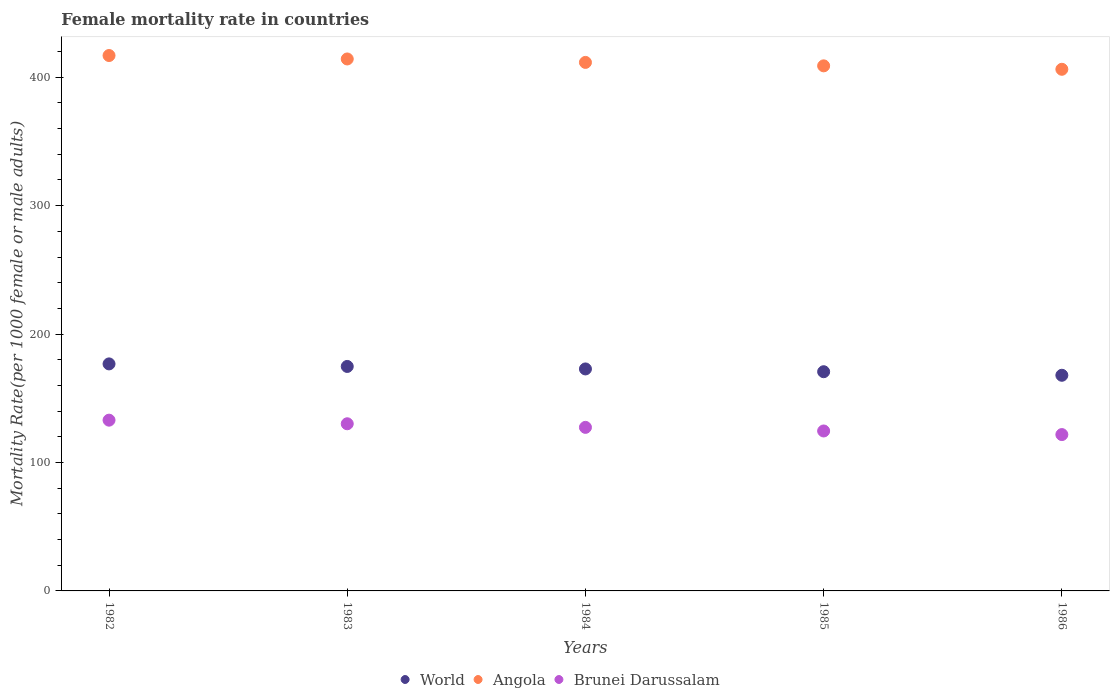Is the number of dotlines equal to the number of legend labels?
Your answer should be very brief. Yes. What is the female mortality rate in World in 1985?
Provide a succinct answer. 170.69. Across all years, what is the maximum female mortality rate in Angola?
Give a very brief answer. 416.9. Across all years, what is the minimum female mortality rate in Brunei Darussalam?
Your answer should be compact. 121.74. What is the total female mortality rate in Brunei Darussalam in the graph?
Provide a short and direct response. 636.77. What is the difference between the female mortality rate in Brunei Darussalam in 1983 and that in 1984?
Offer a terse response. 2.81. What is the difference between the female mortality rate in Brunei Darussalam in 1984 and the female mortality rate in Angola in 1986?
Give a very brief answer. -278.83. What is the average female mortality rate in Brunei Darussalam per year?
Your answer should be very brief. 127.35. In the year 1982, what is the difference between the female mortality rate in World and female mortality rate in Angola?
Make the answer very short. -240.12. What is the ratio of the female mortality rate in Angola in 1982 to that in 1986?
Provide a succinct answer. 1.03. Is the female mortality rate in World in 1984 less than that in 1985?
Provide a succinct answer. No. Is the difference between the female mortality rate in World in 1983 and 1986 greater than the difference between the female mortality rate in Angola in 1983 and 1986?
Offer a very short reply. No. What is the difference between the highest and the second highest female mortality rate in Brunei Darussalam?
Ensure brevity in your answer.  2.81. What is the difference between the highest and the lowest female mortality rate in Brunei Darussalam?
Offer a terse response. 11.22. In how many years, is the female mortality rate in Brunei Darussalam greater than the average female mortality rate in Brunei Darussalam taken over all years?
Your answer should be very brief. 2. Is the sum of the female mortality rate in Angola in 1982 and 1985 greater than the maximum female mortality rate in World across all years?
Your answer should be compact. Yes. Does the female mortality rate in World monotonically increase over the years?
Your answer should be very brief. No. Is the female mortality rate in Brunei Darussalam strictly greater than the female mortality rate in Angola over the years?
Make the answer very short. No. Is the female mortality rate in World strictly less than the female mortality rate in Brunei Darussalam over the years?
Ensure brevity in your answer.  No. Are the values on the major ticks of Y-axis written in scientific E-notation?
Offer a very short reply. No. Does the graph contain any zero values?
Offer a very short reply. No. Does the graph contain grids?
Offer a terse response. No. How are the legend labels stacked?
Your response must be concise. Horizontal. What is the title of the graph?
Your answer should be compact. Female mortality rate in countries. Does "Canada" appear as one of the legend labels in the graph?
Provide a short and direct response. No. What is the label or title of the X-axis?
Keep it short and to the point. Years. What is the label or title of the Y-axis?
Offer a very short reply. Mortality Rate(per 1000 female or male adults). What is the Mortality Rate(per 1000 female or male adults) of World in 1982?
Provide a succinct answer. 176.78. What is the Mortality Rate(per 1000 female or male adults) of Angola in 1982?
Your answer should be compact. 416.9. What is the Mortality Rate(per 1000 female or male adults) in Brunei Darussalam in 1982?
Offer a terse response. 132.97. What is the Mortality Rate(per 1000 female or male adults) in World in 1983?
Keep it short and to the point. 174.79. What is the Mortality Rate(per 1000 female or male adults) in Angola in 1983?
Offer a very short reply. 414.22. What is the Mortality Rate(per 1000 female or male adults) of Brunei Darussalam in 1983?
Provide a succinct answer. 130.16. What is the Mortality Rate(per 1000 female or male adults) in World in 1984?
Keep it short and to the point. 172.85. What is the Mortality Rate(per 1000 female or male adults) in Angola in 1984?
Offer a terse response. 411.54. What is the Mortality Rate(per 1000 female or male adults) in Brunei Darussalam in 1984?
Keep it short and to the point. 127.35. What is the Mortality Rate(per 1000 female or male adults) of World in 1985?
Keep it short and to the point. 170.69. What is the Mortality Rate(per 1000 female or male adults) in Angola in 1985?
Keep it short and to the point. 408.86. What is the Mortality Rate(per 1000 female or male adults) of Brunei Darussalam in 1985?
Ensure brevity in your answer.  124.55. What is the Mortality Rate(per 1000 female or male adults) in World in 1986?
Your answer should be very brief. 167.92. What is the Mortality Rate(per 1000 female or male adults) in Angola in 1986?
Provide a short and direct response. 406.19. What is the Mortality Rate(per 1000 female or male adults) of Brunei Darussalam in 1986?
Offer a terse response. 121.74. Across all years, what is the maximum Mortality Rate(per 1000 female or male adults) in World?
Provide a succinct answer. 176.78. Across all years, what is the maximum Mortality Rate(per 1000 female or male adults) of Angola?
Make the answer very short. 416.9. Across all years, what is the maximum Mortality Rate(per 1000 female or male adults) in Brunei Darussalam?
Provide a short and direct response. 132.97. Across all years, what is the minimum Mortality Rate(per 1000 female or male adults) of World?
Offer a very short reply. 167.92. Across all years, what is the minimum Mortality Rate(per 1000 female or male adults) of Angola?
Your answer should be compact. 406.19. Across all years, what is the minimum Mortality Rate(per 1000 female or male adults) of Brunei Darussalam?
Provide a succinct answer. 121.74. What is the total Mortality Rate(per 1000 female or male adults) in World in the graph?
Provide a succinct answer. 863.03. What is the total Mortality Rate(per 1000 female or male adults) in Angola in the graph?
Your answer should be compact. 2057.71. What is the total Mortality Rate(per 1000 female or male adults) of Brunei Darussalam in the graph?
Offer a terse response. 636.77. What is the difference between the Mortality Rate(per 1000 female or male adults) of World in 1982 and that in 1983?
Your answer should be very brief. 1.98. What is the difference between the Mortality Rate(per 1000 female or male adults) in Angola in 1982 and that in 1983?
Make the answer very short. 2.68. What is the difference between the Mortality Rate(per 1000 female or male adults) of Brunei Darussalam in 1982 and that in 1983?
Offer a terse response. 2.81. What is the difference between the Mortality Rate(per 1000 female or male adults) in World in 1982 and that in 1984?
Keep it short and to the point. 3.93. What is the difference between the Mortality Rate(per 1000 female or male adults) in Angola in 1982 and that in 1984?
Your answer should be compact. 5.36. What is the difference between the Mortality Rate(per 1000 female or male adults) in Brunei Darussalam in 1982 and that in 1984?
Provide a succinct answer. 5.61. What is the difference between the Mortality Rate(per 1000 female or male adults) in World in 1982 and that in 1985?
Make the answer very short. 6.09. What is the difference between the Mortality Rate(per 1000 female or male adults) of Angola in 1982 and that in 1985?
Your answer should be compact. 8.04. What is the difference between the Mortality Rate(per 1000 female or male adults) in Brunei Darussalam in 1982 and that in 1985?
Ensure brevity in your answer.  8.42. What is the difference between the Mortality Rate(per 1000 female or male adults) of World in 1982 and that in 1986?
Offer a terse response. 8.86. What is the difference between the Mortality Rate(per 1000 female or male adults) in Angola in 1982 and that in 1986?
Offer a terse response. 10.71. What is the difference between the Mortality Rate(per 1000 female or male adults) in Brunei Darussalam in 1982 and that in 1986?
Provide a succinct answer. 11.22. What is the difference between the Mortality Rate(per 1000 female or male adults) of World in 1983 and that in 1984?
Provide a succinct answer. 1.94. What is the difference between the Mortality Rate(per 1000 female or male adults) of Angola in 1983 and that in 1984?
Make the answer very short. 2.68. What is the difference between the Mortality Rate(per 1000 female or male adults) of Brunei Darussalam in 1983 and that in 1984?
Give a very brief answer. 2.81. What is the difference between the Mortality Rate(per 1000 female or male adults) in World in 1983 and that in 1985?
Your response must be concise. 4.1. What is the difference between the Mortality Rate(per 1000 female or male adults) of Angola in 1983 and that in 1985?
Offer a terse response. 5.36. What is the difference between the Mortality Rate(per 1000 female or male adults) of Brunei Darussalam in 1983 and that in 1985?
Give a very brief answer. 5.61. What is the difference between the Mortality Rate(per 1000 female or male adults) of World in 1983 and that in 1986?
Your response must be concise. 6.88. What is the difference between the Mortality Rate(per 1000 female or male adults) in Angola in 1983 and that in 1986?
Offer a terse response. 8.04. What is the difference between the Mortality Rate(per 1000 female or male adults) in Brunei Darussalam in 1983 and that in 1986?
Offer a terse response. 8.42. What is the difference between the Mortality Rate(per 1000 female or male adults) in World in 1984 and that in 1985?
Provide a succinct answer. 2.16. What is the difference between the Mortality Rate(per 1000 female or male adults) of Angola in 1984 and that in 1985?
Ensure brevity in your answer.  2.68. What is the difference between the Mortality Rate(per 1000 female or male adults) in Brunei Darussalam in 1984 and that in 1985?
Provide a succinct answer. 2.81. What is the difference between the Mortality Rate(per 1000 female or male adults) of World in 1984 and that in 1986?
Provide a short and direct response. 4.93. What is the difference between the Mortality Rate(per 1000 female or male adults) of Angola in 1984 and that in 1986?
Offer a very short reply. 5.36. What is the difference between the Mortality Rate(per 1000 female or male adults) of Brunei Darussalam in 1984 and that in 1986?
Your answer should be compact. 5.61. What is the difference between the Mortality Rate(per 1000 female or male adults) of World in 1985 and that in 1986?
Offer a terse response. 2.77. What is the difference between the Mortality Rate(per 1000 female or male adults) of Angola in 1985 and that in 1986?
Make the answer very short. 2.68. What is the difference between the Mortality Rate(per 1000 female or male adults) in Brunei Darussalam in 1985 and that in 1986?
Offer a very short reply. 2.81. What is the difference between the Mortality Rate(per 1000 female or male adults) of World in 1982 and the Mortality Rate(per 1000 female or male adults) of Angola in 1983?
Make the answer very short. -237.44. What is the difference between the Mortality Rate(per 1000 female or male adults) in World in 1982 and the Mortality Rate(per 1000 female or male adults) in Brunei Darussalam in 1983?
Provide a succinct answer. 46.62. What is the difference between the Mortality Rate(per 1000 female or male adults) of Angola in 1982 and the Mortality Rate(per 1000 female or male adults) of Brunei Darussalam in 1983?
Your response must be concise. 286.74. What is the difference between the Mortality Rate(per 1000 female or male adults) in World in 1982 and the Mortality Rate(per 1000 female or male adults) in Angola in 1984?
Provide a short and direct response. -234.76. What is the difference between the Mortality Rate(per 1000 female or male adults) in World in 1982 and the Mortality Rate(per 1000 female or male adults) in Brunei Darussalam in 1984?
Provide a succinct answer. 49.42. What is the difference between the Mortality Rate(per 1000 female or male adults) in Angola in 1982 and the Mortality Rate(per 1000 female or male adults) in Brunei Darussalam in 1984?
Offer a very short reply. 289.55. What is the difference between the Mortality Rate(per 1000 female or male adults) of World in 1982 and the Mortality Rate(per 1000 female or male adults) of Angola in 1985?
Your response must be concise. -232.09. What is the difference between the Mortality Rate(per 1000 female or male adults) of World in 1982 and the Mortality Rate(per 1000 female or male adults) of Brunei Darussalam in 1985?
Give a very brief answer. 52.23. What is the difference between the Mortality Rate(per 1000 female or male adults) in Angola in 1982 and the Mortality Rate(per 1000 female or male adults) in Brunei Darussalam in 1985?
Offer a terse response. 292.35. What is the difference between the Mortality Rate(per 1000 female or male adults) of World in 1982 and the Mortality Rate(per 1000 female or male adults) of Angola in 1986?
Make the answer very short. -229.41. What is the difference between the Mortality Rate(per 1000 female or male adults) in World in 1982 and the Mortality Rate(per 1000 female or male adults) in Brunei Darussalam in 1986?
Your answer should be very brief. 55.04. What is the difference between the Mortality Rate(per 1000 female or male adults) in Angola in 1982 and the Mortality Rate(per 1000 female or male adults) in Brunei Darussalam in 1986?
Make the answer very short. 295.16. What is the difference between the Mortality Rate(per 1000 female or male adults) in World in 1983 and the Mortality Rate(per 1000 female or male adults) in Angola in 1984?
Offer a terse response. -236.75. What is the difference between the Mortality Rate(per 1000 female or male adults) of World in 1983 and the Mortality Rate(per 1000 female or male adults) of Brunei Darussalam in 1984?
Provide a succinct answer. 47.44. What is the difference between the Mortality Rate(per 1000 female or male adults) of Angola in 1983 and the Mortality Rate(per 1000 female or male adults) of Brunei Darussalam in 1984?
Provide a succinct answer. 286.87. What is the difference between the Mortality Rate(per 1000 female or male adults) of World in 1983 and the Mortality Rate(per 1000 female or male adults) of Angola in 1985?
Your answer should be very brief. -234.07. What is the difference between the Mortality Rate(per 1000 female or male adults) of World in 1983 and the Mortality Rate(per 1000 female or male adults) of Brunei Darussalam in 1985?
Give a very brief answer. 50.24. What is the difference between the Mortality Rate(per 1000 female or male adults) of Angola in 1983 and the Mortality Rate(per 1000 female or male adults) of Brunei Darussalam in 1985?
Keep it short and to the point. 289.67. What is the difference between the Mortality Rate(per 1000 female or male adults) of World in 1983 and the Mortality Rate(per 1000 female or male adults) of Angola in 1986?
Keep it short and to the point. -231.39. What is the difference between the Mortality Rate(per 1000 female or male adults) of World in 1983 and the Mortality Rate(per 1000 female or male adults) of Brunei Darussalam in 1986?
Provide a short and direct response. 53.05. What is the difference between the Mortality Rate(per 1000 female or male adults) of Angola in 1983 and the Mortality Rate(per 1000 female or male adults) of Brunei Darussalam in 1986?
Provide a short and direct response. 292.48. What is the difference between the Mortality Rate(per 1000 female or male adults) in World in 1984 and the Mortality Rate(per 1000 female or male adults) in Angola in 1985?
Make the answer very short. -236.01. What is the difference between the Mortality Rate(per 1000 female or male adults) of World in 1984 and the Mortality Rate(per 1000 female or male adults) of Brunei Darussalam in 1985?
Keep it short and to the point. 48.3. What is the difference between the Mortality Rate(per 1000 female or male adults) in Angola in 1984 and the Mortality Rate(per 1000 female or male adults) in Brunei Darussalam in 1985?
Make the answer very short. 286.99. What is the difference between the Mortality Rate(per 1000 female or male adults) in World in 1984 and the Mortality Rate(per 1000 female or male adults) in Angola in 1986?
Provide a succinct answer. -233.33. What is the difference between the Mortality Rate(per 1000 female or male adults) of World in 1984 and the Mortality Rate(per 1000 female or male adults) of Brunei Darussalam in 1986?
Keep it short and to the point. 51.11. What is the difference between the Mortality Rate(per 1000 female or male adults) of Angola in 1984 and the Mortality Rate(per 1000 female or male adults) of Brunei Darussalam in 1986?
Make the answer very short. 289.8. What is the difference between the Mortality Rate(per 1000 female or male adults) of World in 1985 and the Mortality Rate(per 1000 female or male adults) of Angola in 1986?
Ensure brevity in your answer.  -235.5. What is the difference between the Mortality Rate(per 1000 female or male adults) in World in 1985 and the Mortality Rate(per 1000 female or male adults) in Brunei Darussalam in 1986?
Provide a short and direct response. 48.95. What is the difference between the Mortality Rate(per 1000 female or male adults) of Angola in 1985 and the Mortality Rate(per 1000 female or male adults) of Brunei Darussalam in 1986?
Your response must be concise. 287.12. What is the average Mortality Rate(per 1000 female or male adults) in World per year?
Give a very brief answer. 172.61. What is the average Mortality Rate(per 1000 female or male adults) of Angola per year?
Offer a very short reply. 411.54. What is the average Mortality Rate(per 1000 female or male adults) of Brunei Darussalam per year?
Your response must be concise. 127.35. In the year 1982, what is the difference between the Mortality Rate(per 1000 female or male adults) of World and Mortality Rate(per 1000 female or male adults) of Angola?
Provide a short and direct response. -240.12. In the year 1982, what is the difference between the Mortality Rate(per 1000 female or male adults) in World and Mortality Rate(per 1000 female or male adults) in Brunei Darussalam?
Give a very brief answer. 43.81. In the year 1982, what is the difference between the Mortality Rate(per 1000 female or male adults) of Angola and Mortality Rate(per 1000 female or male adults) of Brunei Darussalam?
Your answer should be very brief. 283.93. In the year 1983, what is the difference between the Mortality Rate(per 1000 female or male adults) in World and Mortality Rate(per 1000 female or male adults) in Angola?
Your response must be concise. -239.43. In the year 1983, what is the difference between the Mortality Rate(per 1000 female or male adults) of World and Mortality Rate(per 1000 female or male adults) of Brunei Darussalam?
Provide a short and direct response. 44.63. In the year 1983, what is the difference between the Mortality Rate(per 1000 female or male adults) in Angola and Mortality Rate(per 1000 female or male adults) in Brunei Darussalam?
Provide a short and direct response. 284.06. In the year 1984, what is the difference between the Mortality Rate(per 1000 female or male adults) in World and Mortality Rate(per 1000 female or male adults) in Angola?
Your answer should be very brief. -238.69. In the year 1984, what is the difference between the Mortality Rate(per 1000 female or male adults) of World and Mortality Rate(per 1000 female or male adults) of Brunei Darussalam?
Your answer should be compact. 45.5. In the year 1984, what is the difference between the Mortality Rate(per 1000 female or male adults) of Angola and Mortality Rate(per 1000 female or male adults) of Brunei Darussalam?
Your answer should be compact. 284.19. In the year 1985, what is the difference between the Mortality Rate(per 1000 female or male adults) in World and Mortality Rate(per 1000 female or male adults) in Angola?
Ensure brevity in your answer.  -238.18. In the year 1985, what is the difference between the Mortality Rate(per 1000 female or male adults) in World and Mortality Rate(per 1000 female or male adults) in Brunei Darussalam?
Your answer should be compact. 46.14. In the year 1985, what is the difference between the Mortality Rate(per 1000 female or male adults) in Angola and Mortality Rate(per 1000 female or male adults) in Brunei Darussalam?
Offer a very short reply. 284.32. In the year 1986, what is the difference between the Mortality Rate(per 1000 female or male adults) in World and Mortality Rate(per 1000 female or male adults) in Angola?
Your answer should be compact. -238.27. In the year 1986, what is the difference between the Mortality Rate(per 1000 female or male adults) in World and Mortality Rate(per 1000 female or male adults) in Brunei Darussalam?
Make the answer very short. 46.18. In the year 1986, what is the difference between the Mortality Rate(per 1000 female or male adults) in Angola and Mortality Rate(per 1000 female or male adults) in Brunei Darussalam?
Your answer should be compact. 284.44. What is the ratio of the Mortality Rate(per 1000 female or male adults) of World in 1982 to that in 1983?
Provide a short and direct response. 1.01. What is the ratio of the Mortality Rate(per 1000 female or male adults) in Brunei Darussalam in 1982 to that in 1983?
Offer a very short reply. 1.02. What is the ratio of the Mortality Rate(per 1000 female or male adults) of World in 1982 to that in 1984?
Keep it short and to the point. 1.02. What is the ratio of the Mortality Rate(per 1000 female or male adults) of Angola in 1982 to that in 1984?
Your response must be concise. 1.01. What is the ratio of the Mortality Rate(per 1000 female or male adults) in Brunei Darussalam in 1982 to that in 1984?
Your answer should be very brief. 1.04. What is the ratio of the Mortality Rate(per 1000 female or male adults) in World in 1982 to that in 1985?
Offer a very short reply. 1.04. What is the ratio of the Mortality Rate(per 1000 female or male adults) of Angola in 1982 to that in 1985?
Your answer should be very brief. 1.02. What is the ratio of the Mortality Rate(per 1000 female or male adults) in Brunei Darussalam in 1982 to that in 1985?
Your response must be concise. 1.07. What is the ratio of the Mortality Rate(per 1000 female or male adults) of World in 1982 to that in 1986?
Give a very brief answer. 1.05. What is the ratio of the Mortality Rate(per 1000 female or male adults) in Angola in 1982 to that in 1986?
Offer a very short reply. 1.03. What is the ratio of the Mortality Rate(per 1000 female or male adults) of Brunei Darussalam in 1982 to that in 1986?
Offer a very short reply. 1.09. What is the ratio of the Mortality Rate(per 1000 female or male adults) of World in 1983 to that in 1984?
Provide a succinct answer. 1.01. What is the ratio of the Mortality Rate(per 1000 female or male adults) of World in 1983 to that in 1985?
Provide a short and direct response. 1.02. What is the ratio of the Mortality Rate(per 1000 female or male adults) of Angola in 1983 to that in 1985?
Give a very brief answer. 1.01. What is the ratio of the Mortality Rate(per 1000 female or male adults) in Brunei Darussalam in 1983 to that in 1985?
Provide a short and direct response. 1.05. What is the ratio of the Mortality Rate(per 1000 female or male adults) of World in 1983 to that in 1986?
Offer a terse response. 1.04. What is the ratio of the Mortality Rate(per 1000 female or male adults) of Angola in 1983 to that in 1986?
Keep it short and to the point. 1.02. What is the ratio of the Mortality Rate(per 1000 female or male adults) in Brunei Darussalam in 1983 to that in 1986?
Ensure brevity in your answer.  1.07. What is the ratio of the Mortality Rate(per 1000 female or male adults) of World in 1984 to that in 1985?
Make the answer very short. 1.01. What is the ratio of the Mortality Rate(per 1000 female or male adults) in Angola in 1984 to that in 1985?
Keep it short and to the point. 1.01. What is the ratio of the Mortality Rate(per 1000 female or male adults) in Brunei Darussalam in 1984 to that in 1985?
Your answer should be compact. 1.02. What is the ratio of the Mortality Rate(per 1000 female or male adults) in World in 1984 to that in 1986?
Your answer should be compact. 1.03. What is the ratio of the Mortality Rate(per 1000 female or male adults) in Angola in 1984 to that in 1986?
Give a very brief answer. 1.01. What is the ratio of the Mortality Rate(per 1000 female or male adults) in Brunei Darussalam in 1984 to that in 1986?
Make the answer very short. 1.05. What is the ratio of the Mortality Rate(per 1000 female or male adults) of World in 1985 to that in 1986?
Offer a very short reply. 1.02. What is the ratio of the Mortality Rate(per 1000 female or male adults) in Angola in 1985 to that in 1986?
Your answer should be very brief. 1.01. What is the ratio of the Mortality Rate(per 1000 female or male adults) in Brunei Darussalam in 1985 to that in 1986?
Your answer should be very brief. 1.02. What is the difference between the highest and the second highest Mortality Rate(per 1000 female or male adults) in World?
Your answer should be compact. 1.98. What is the difference between the highest and the second highest Mortality Rate(per 1000 female or male adults) of Angola?
Provide a short and direct response. 2.68. What is the difference between the highest and the second highest Mortality Rate(per 1000 female or male adults) in Brunei Darussalam?
Provide a succinct answer. 2.81. What is the difference between the highest and the lowest Mortality Rate(per 1000 female or male adults) in World?
Your answer should be very brief. 8.86. What is the difference between the highest and the lowest Mortality Rate(per 1000 female or male adults) in Angola?
Your answer should be compact. 10.71. What is the difference between the highest and the lowest Mortality Rate(per 1000 female or male adults) of Brunei Darussalam?
Give a very brief answer. 11.22. 